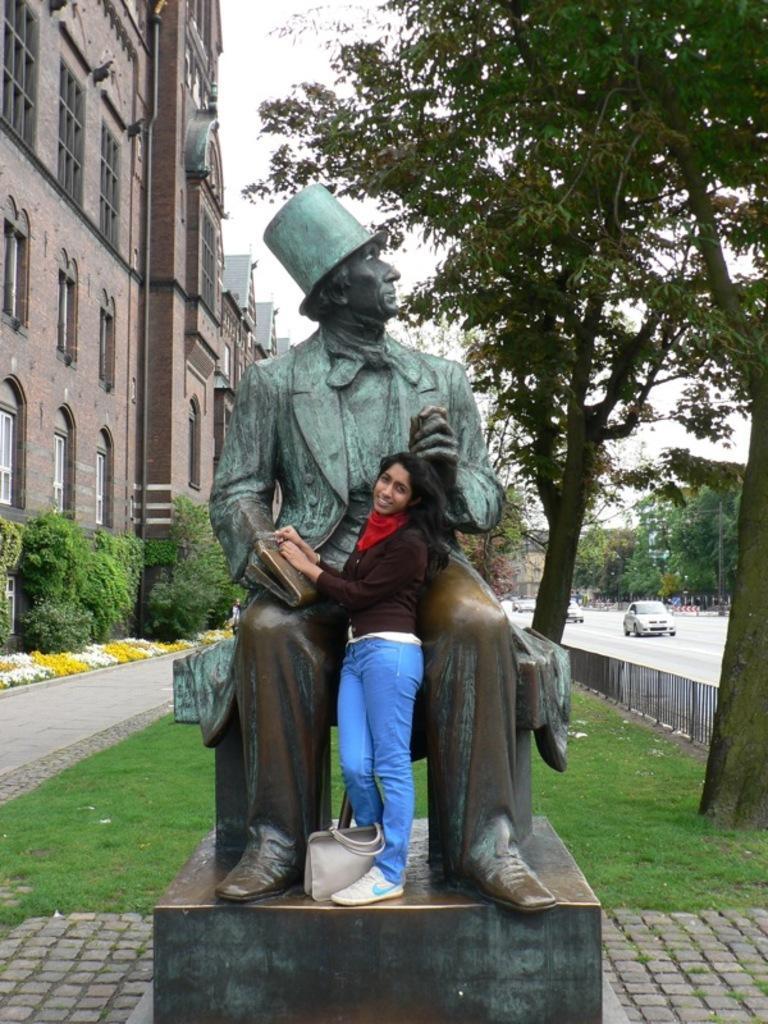Can you describe this image briefly? This is the picture of a lady who is standing in front of the statue and behind there are some buildings, cars, trees and some grass on the floor. 